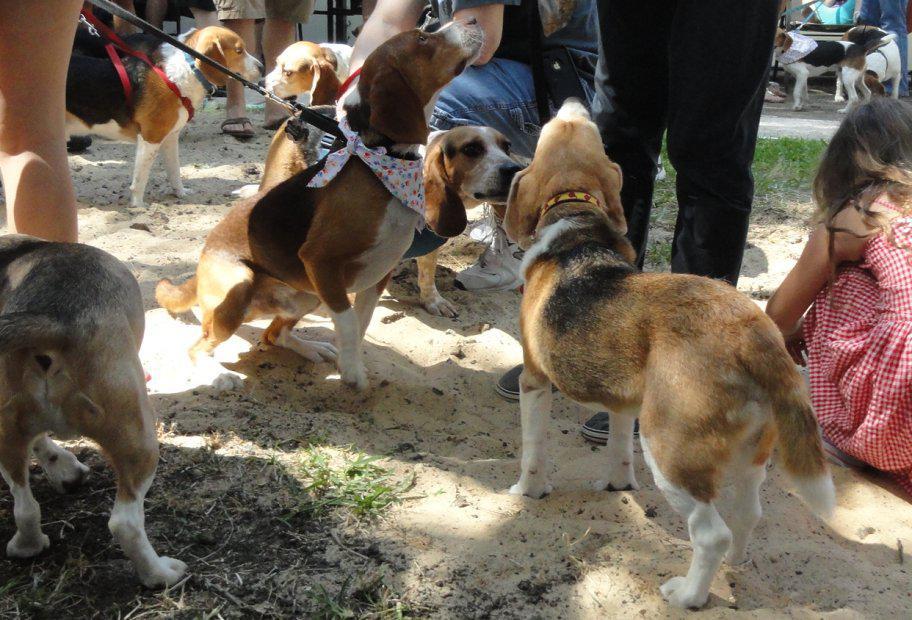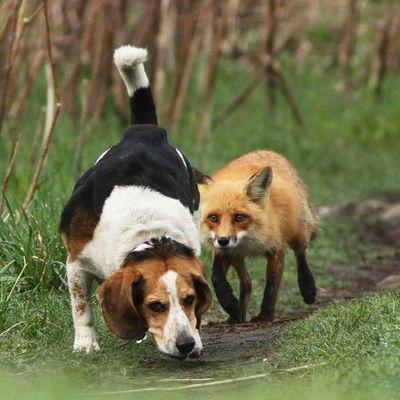The first image is the image on the left, the second image is the image on the right. For the images displayed, is the sentence "There are people near some of the dogs." factually correct? Answer yes or no. Yes. The first image is the image on the left, the second image is the image on the right. Examine the images to the left and right. Is the description "One image contains exactly two animals, at least one of them a beagle." accurate? Answer yes or no. Yes. 